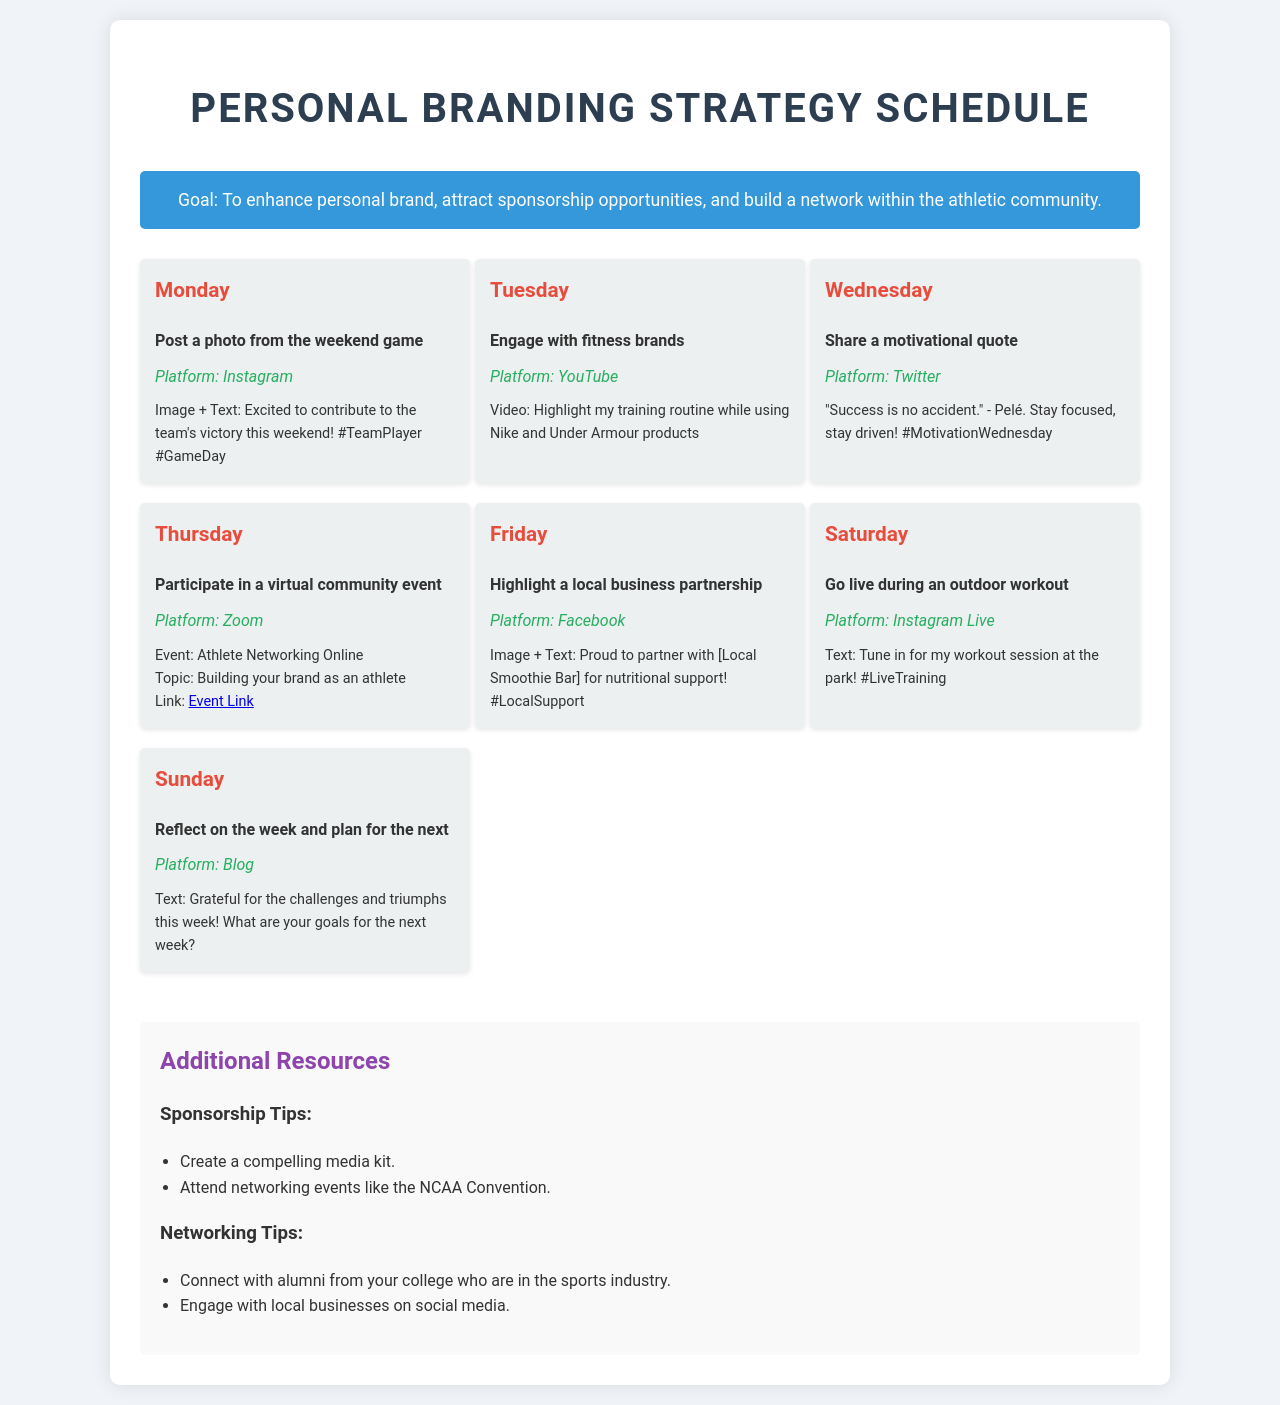What is the goal of the personal branding strategy? The goal is stated clearly in the document as enhancing personal brand, attracting sponsorship opportunities, and building a network within the athletic community.
Answer: To enhance personal brand, attract sponsorship opportunities, and build a network within the athletic community Which platform is used for the motivational quote post? The document indicates that the motivational quote is shared on Twitter.
Answer: Twitter What is the specific event that takes place on Thursday? The event mentioned for Thursday is an athlete networking online session where the focus is on building your brand as an athlete.
Answer: Athlete Networking Online How often does the plan suggest reflecting on the week? According to the schedule, reflecting on the week is planned for Sundays, indicating a weekly frequency.
Answer: Weekly What type of media is used for the Friday post? The Friday post highlights a local business partnership using an image and text.
Answer: Image + Text What should be included in a compelling media kit? The document refers to a media kit as part of the sponsorship tips without specifying details, but implies it contains important promotional materials.
Answer: Compelling media kit What is the main topic of the Zoom event? The topic provided for the Zoom event is focused on building your brand as an athlete.
Answer: Building your brand as an athlete On what day is the athlete going live for a workout session? According to the document, the athlete goes live for an outdoor workout session on Saturday.
Answer: Saturday 